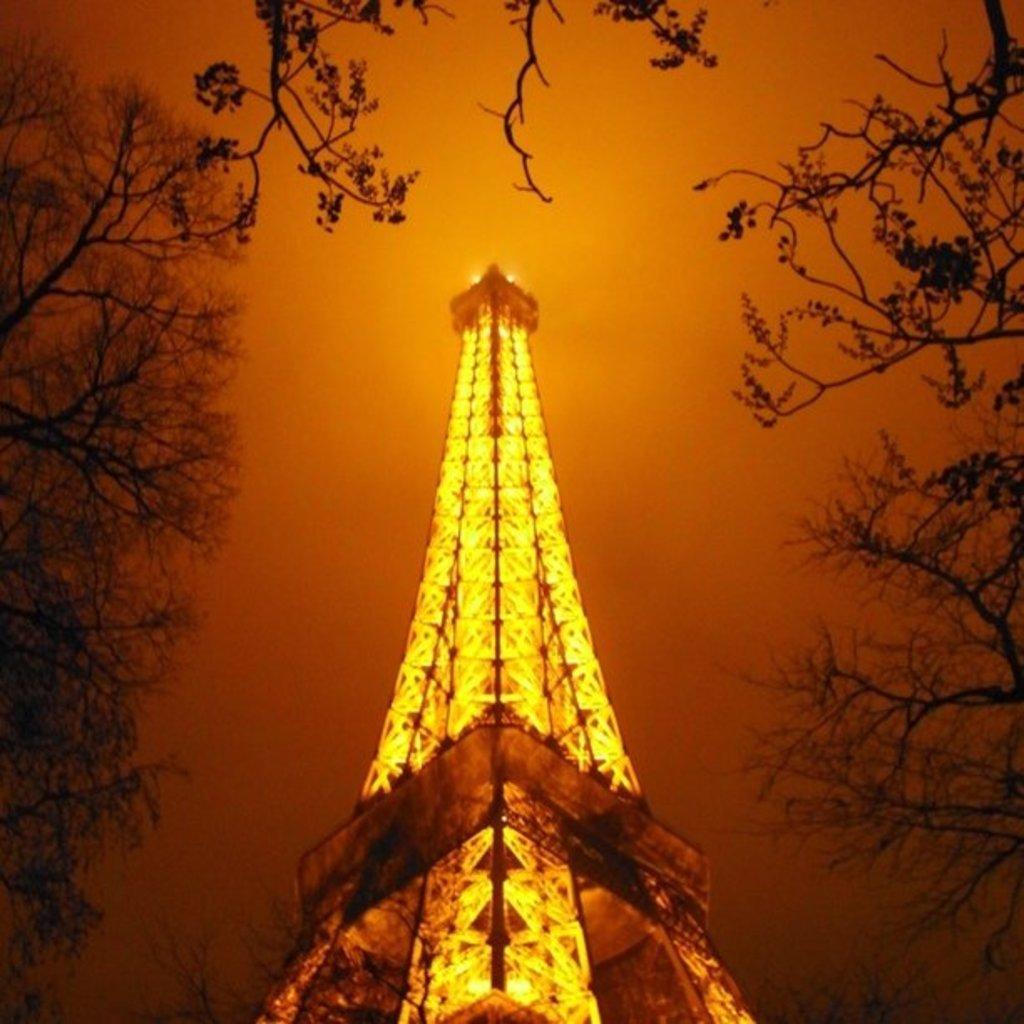Could you give a brief overview of what you see in this image? In this image I can see the tower and I can see few yellow color lights. In the background I can see few trees and the sky. 